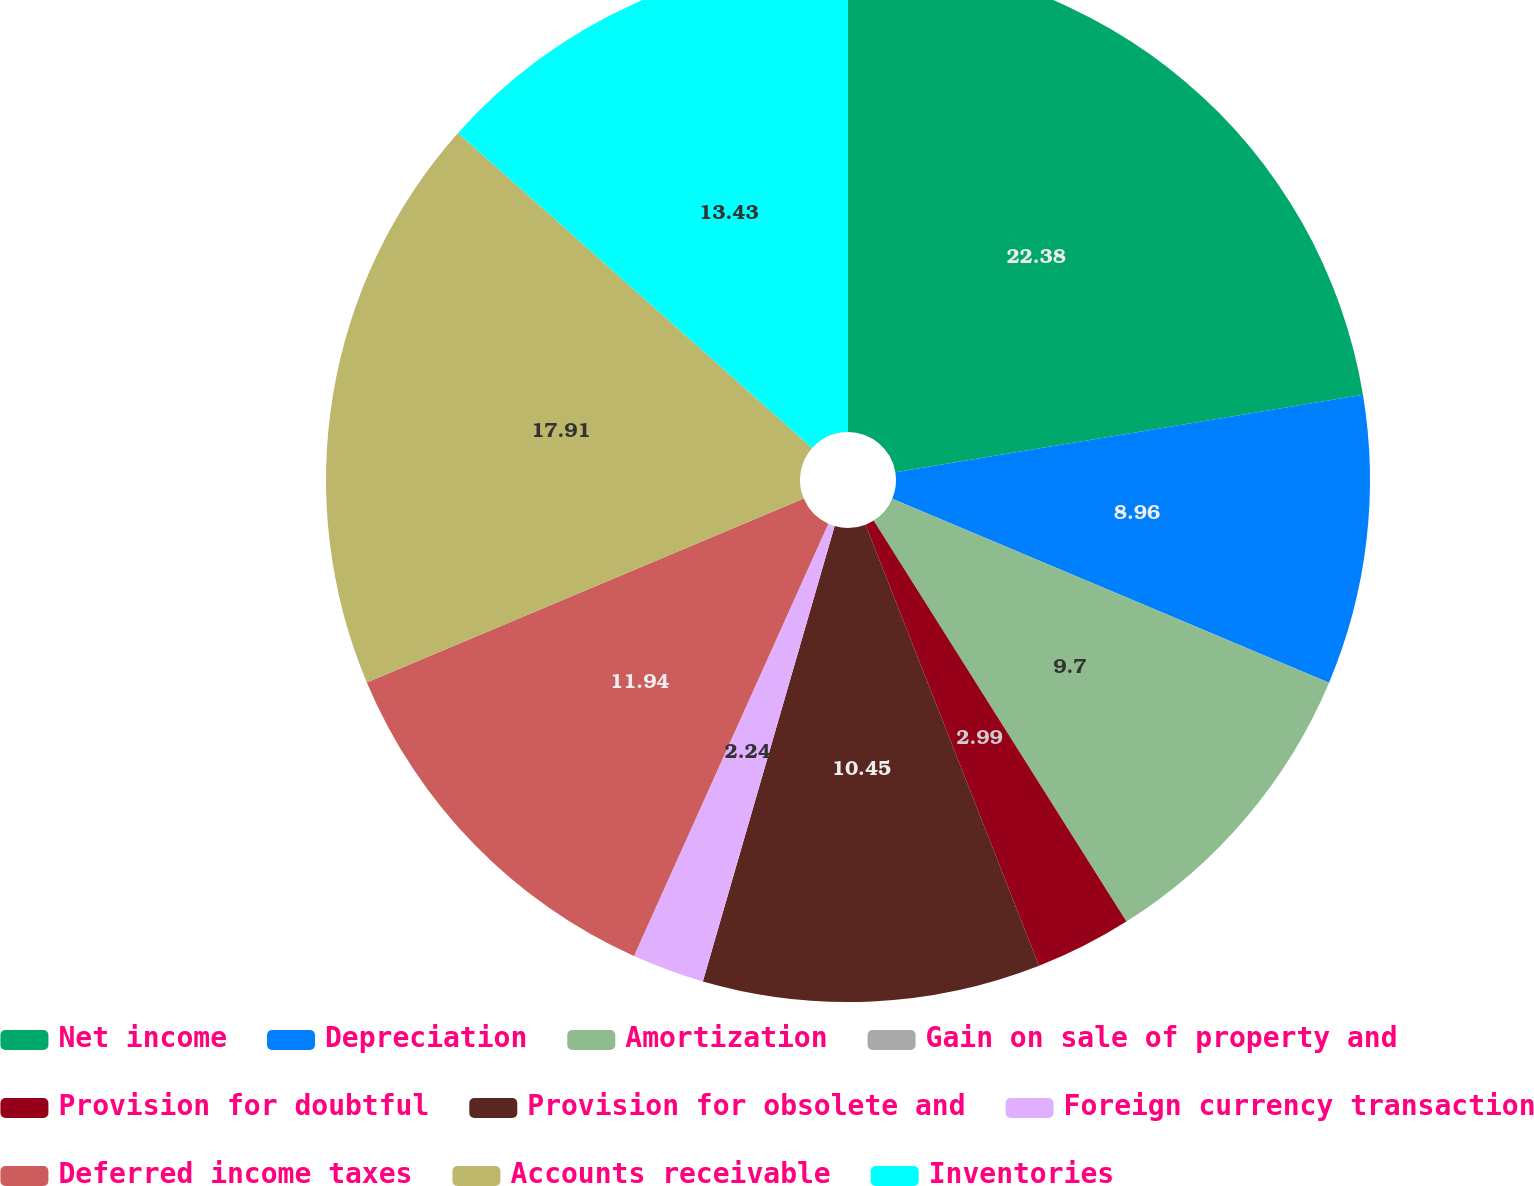Convert chart. <chart><loc_0><loc_0><loc_500><loc_500><pie_chart><fcel>Net income<fcel>Depreciation<fcel>Amortization<fcel>Gain on sale of property and<fcel>Provision for doubtful<fcel>Provision for obsolete and<fcel>Foreign currency transaction<fcel>Deferred income taxes<fcel>Accounts receivable<fcel>Inventories<nl><fcel>22.39%<fcel>8.96%<fcel>9.7%<fcel>0.0%<fcel>2.99%<fcel>10.45%<fcel>2.24%<fcel>11.94%<fcel>17.91%<fcel>13.43%<nl></chart> 